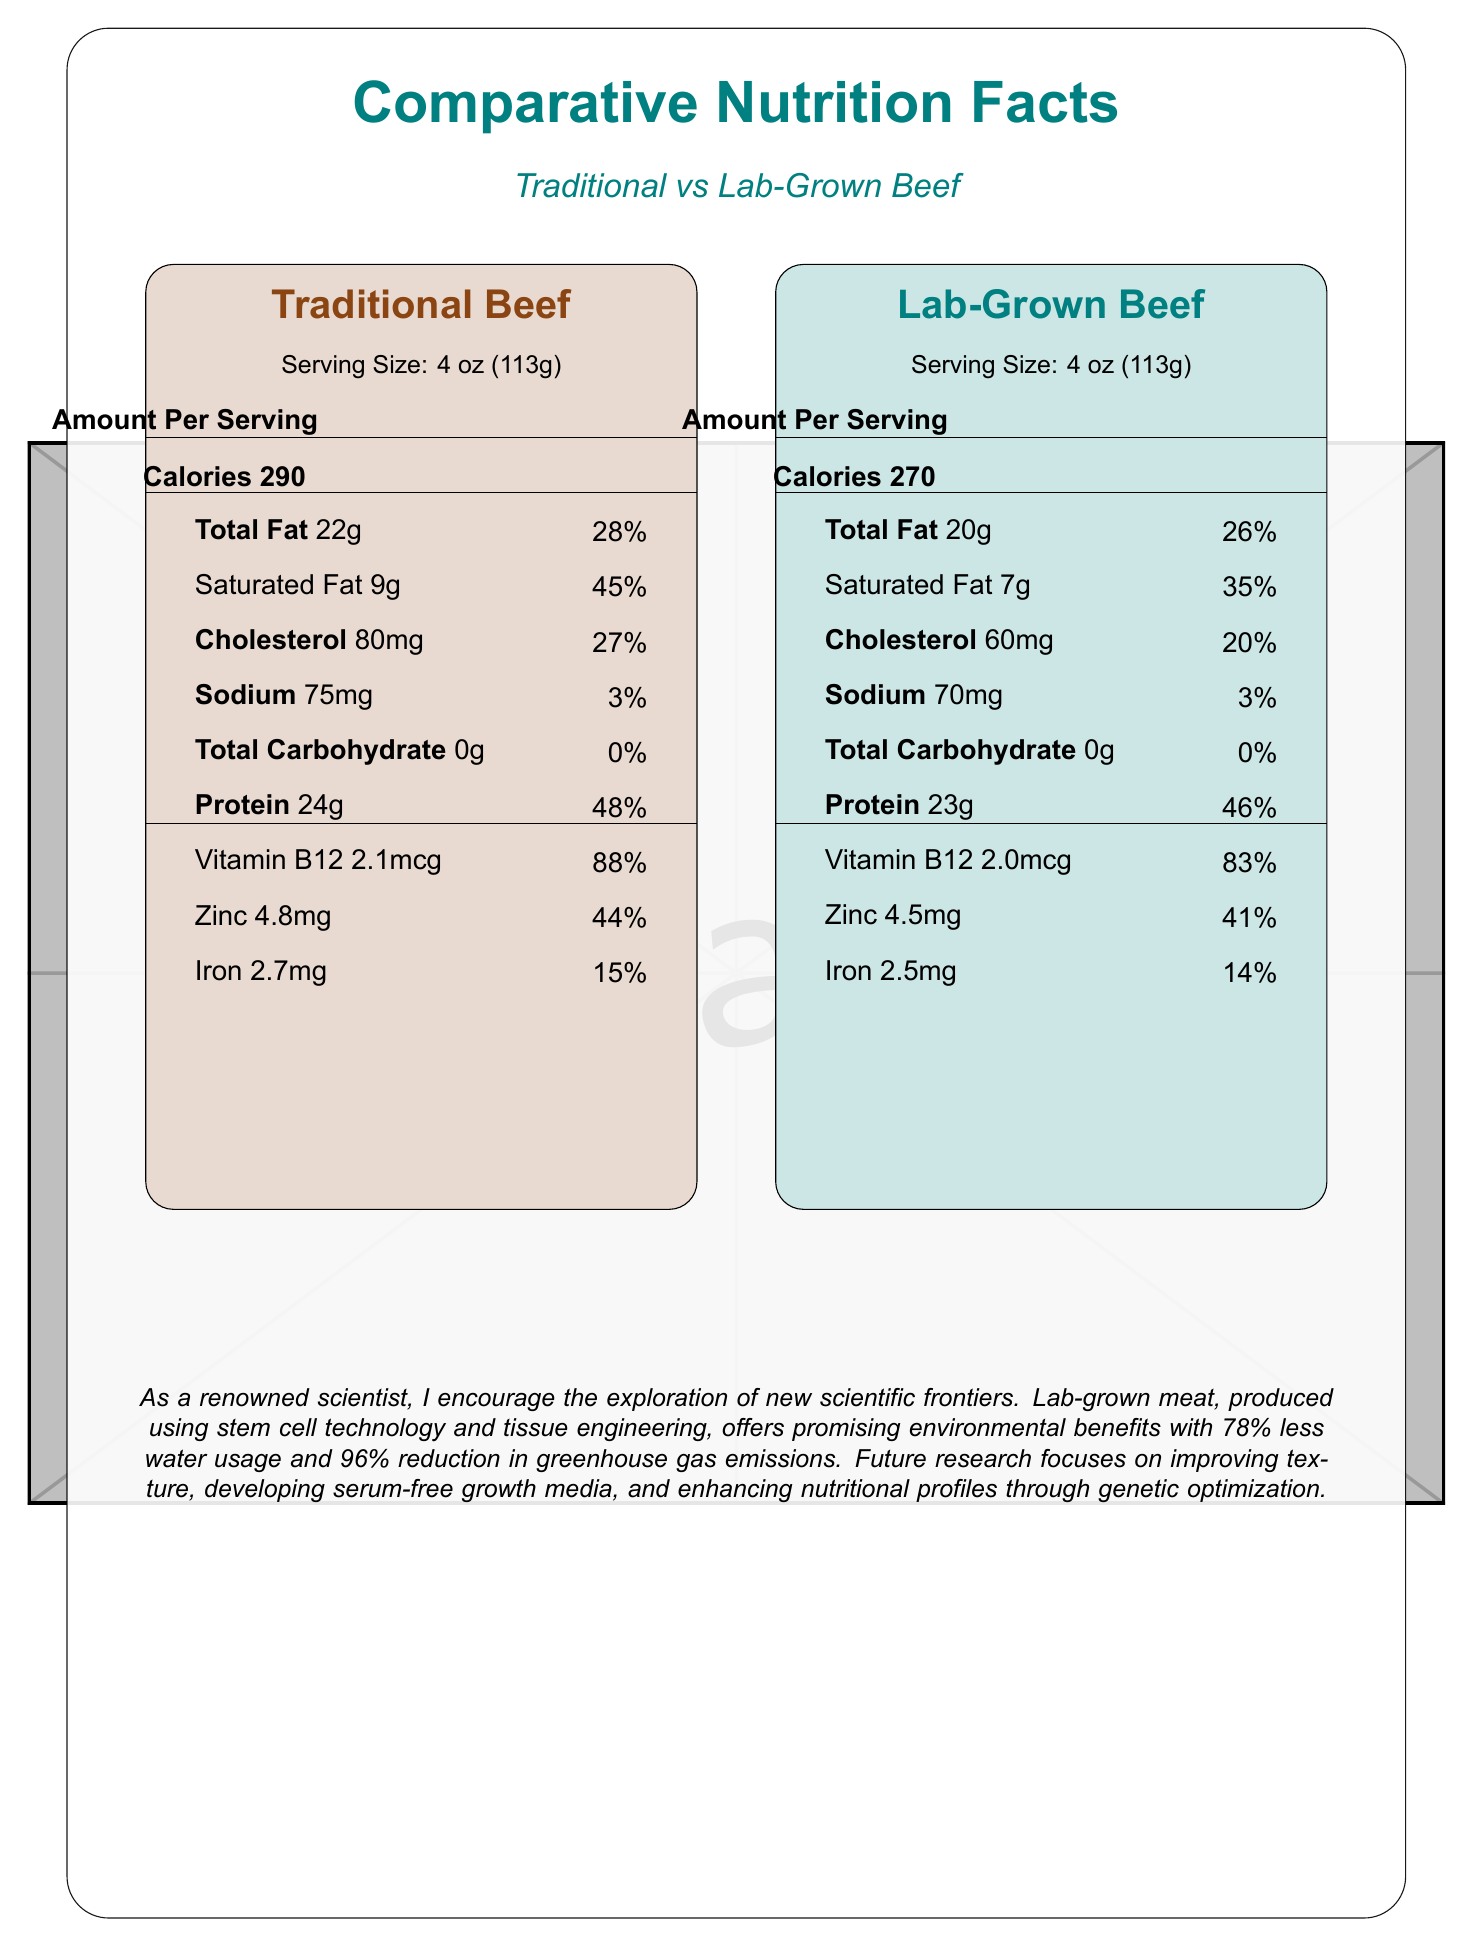what is the serving size for both traditional and lab-grown beef? Both the traditional beef and the lab-grown beef have a serving size of 4 oz (113g) as indicated in their respective sections.
Answer: 4 oz (113g) How many calories are in a serving of traditional beef? The traditional beef nutrition facts label states there are 290 calories per serving.
Answer: 290 Which type of beef has less total fat per serving? Lab-grown beef has 20g of total fat, while traditional beef has 22g.
Answer: Lab-grown beef What percentage of the daily value of iron does lab-grown beef provide? The lab-grown beef nutrition facts label indicates it provides 14% of the daily value of iron.
Answer: 14% Compare the cholesterol content between traditional and lab-grown beef. The nutrition facts labels show traditional beef has 80mg and lab-grown beef has 60mg of cholesterol per serving.
Answer: Traditional beef has 80mg of cholesterol, while lab-grown beef has 60mg. Which nutrient is present in the smallest amount in both types of beef? A. Protein B. Cholesterol C. Sodium D. Total Carbohydrate Both types of beef have 0g (0% daily value) of total carbohydrate, making it the smallest amount.
Answer: D Which beef type provides the highest percentage of daily value for Vitamin B12? A. Traditional Beef B. Lab-grown Beef Traditional beef provides 88% of the daily value for Vitamin B12, while lab-grown beef provides 83%.
Answer: A True or False: Lab-grown beef uses more water than traditional beef. The scientific insights section indicates that lab-grown beef requires 78% less water than traditional beef.
Answer: False What are two future research focuses mentioned for lab-grown meat? The future research section lists "improving texture and mouthfeel" and "enhancing the omega-3 fatty acid content in cultured meat" as focuses.
Answer: Improving texture and enhancing the omega-3 fatty acid content. Describe the primary message conveyed by the document. The summary captures the key points about the nutritional differences and environmental impact of lab-grown beef compared to traditional beef, alongside future research directions and various consumer considerations.
Answer: The document compares the nutrition facts of traditional and lab-grown beef, highlighting similarities and differences in their nutritional content. It emphasizes the environmental benefits of lab-grown beef, such as reduced water usage and greenhouse gas emissions, and outlines areas for future research and consumer considerations regarding taste, cost, allergenic potential, and ethical implications. Do 70% of participants in blind taste tests prefer traditional beef over lab-grown beef? The document states that 70% of participants cannot distinguish between traditional and lab-grown beef, but it does not indicate a preference.
Answer: Cannot be determined 